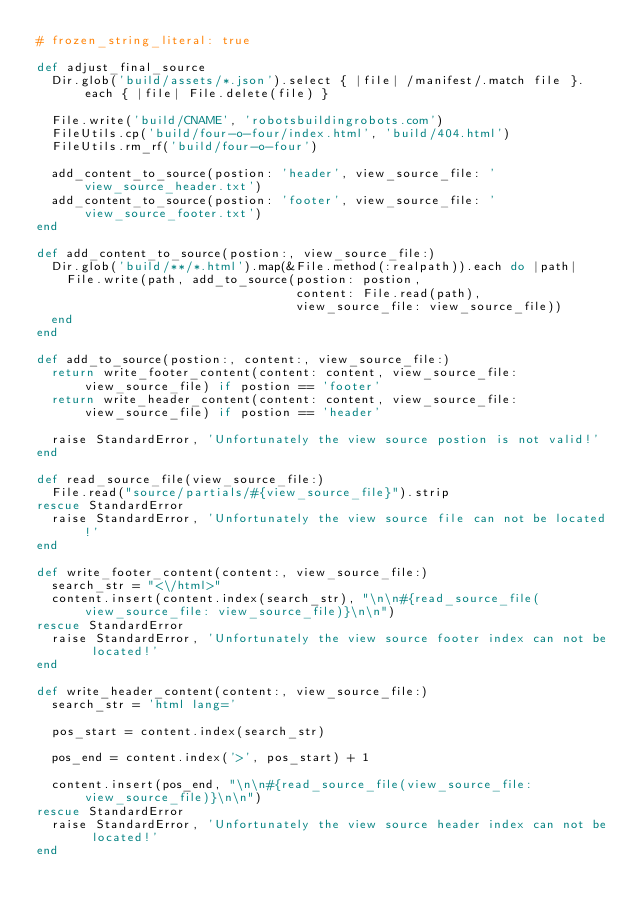Convert code to text. <code><loc_0><loc_0><loc_500><loc_500><_Ruby_># frozen_string_literal: true

def adjust_final_source
  Dir.glob('build/assets/*.json').select { |file| /manifest/.match file }.each { |file| File.delete(file) }

  File.write('build/CNAME', 'robotsbuildingrobots.com')
  FileUtils.cp('build/four-o-four/index.html', 'build/404.html')
  FileUtils.rm_rf('build/four-o-four')

  add_content_to_source(postion: 'header', view_source_file: 'view_source_header.txt')
  add_content_to_source(postion: 'footer', view_source_file: 'view_source_footer.txt')
end

def add_content_to_source(postion:, view_source_file:)
  Dir.glob('build/**/*.html').map(&File.method(:realpath)).each do |path|
    File.write(path, add_to_source(postion: postion,
                                   content: File.read(path),
                                   view_source_file: view_source_file))
  end
end

def add_to_source(postion:, content:, view_source_file:)
  return write_footer_content(content: content, view_source_file: view_source_file) if postion == 'footer'
  return write_header_content(content: content, view_source_file: view_source_file) if postion == 'header'

  raise StandardError, 'Unfortunately the view source postion is not valid!'
end

def read_source_file(view_source_file:)
  File.read("source/partials/#{view_source_file}").strip
rescue StandardError
  raise StandardError, 'Unfortunately the view source file can not be located!'
end

def write_footer_content(content:, view_source_file:)
  search_str = "<\/html>"
  content.insert(content.index(search_str), "\n\n#{read_source_file(view_source_file: view_source_file)}\n\n")
rescue StandardError
  raise StandardError, 'Unfortunately the view source footer index can not be located!'
end

def write_header_content(content:, view_source_file:)
  search_str = 'html lang='

  pos_start = content.index(search_str)

  pos_end = content.index('>', pos_start) + 1

  content.insert(pos_end, "\n\n#{read_source_file(view_source_file: view_source_file)}\n\n")
rescue StandardError
  raise StandardError, 'Unfortunately the view source header index can not be located!'
end
</code> 